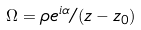Convert formula to latex. <formula><loc_0><loc_0><loc_500><loc_500>\Omega = \rho e ^ { i \alpha } / ( z - z _ { 0 } )</formula> 